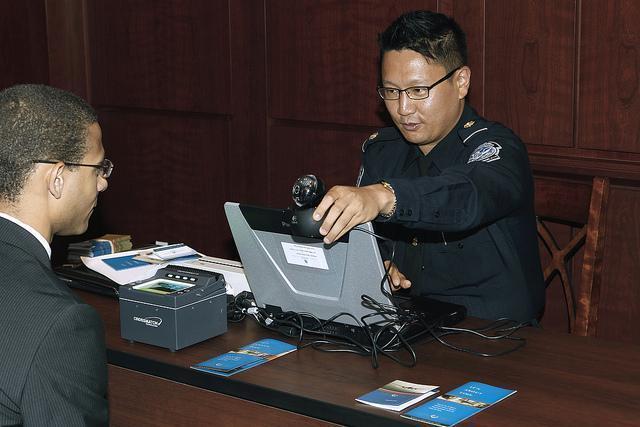How many people in this image are wearing glasses?
Give a very brief answer. 2. How many people can be seen?
Give a very brief answer. 2. 